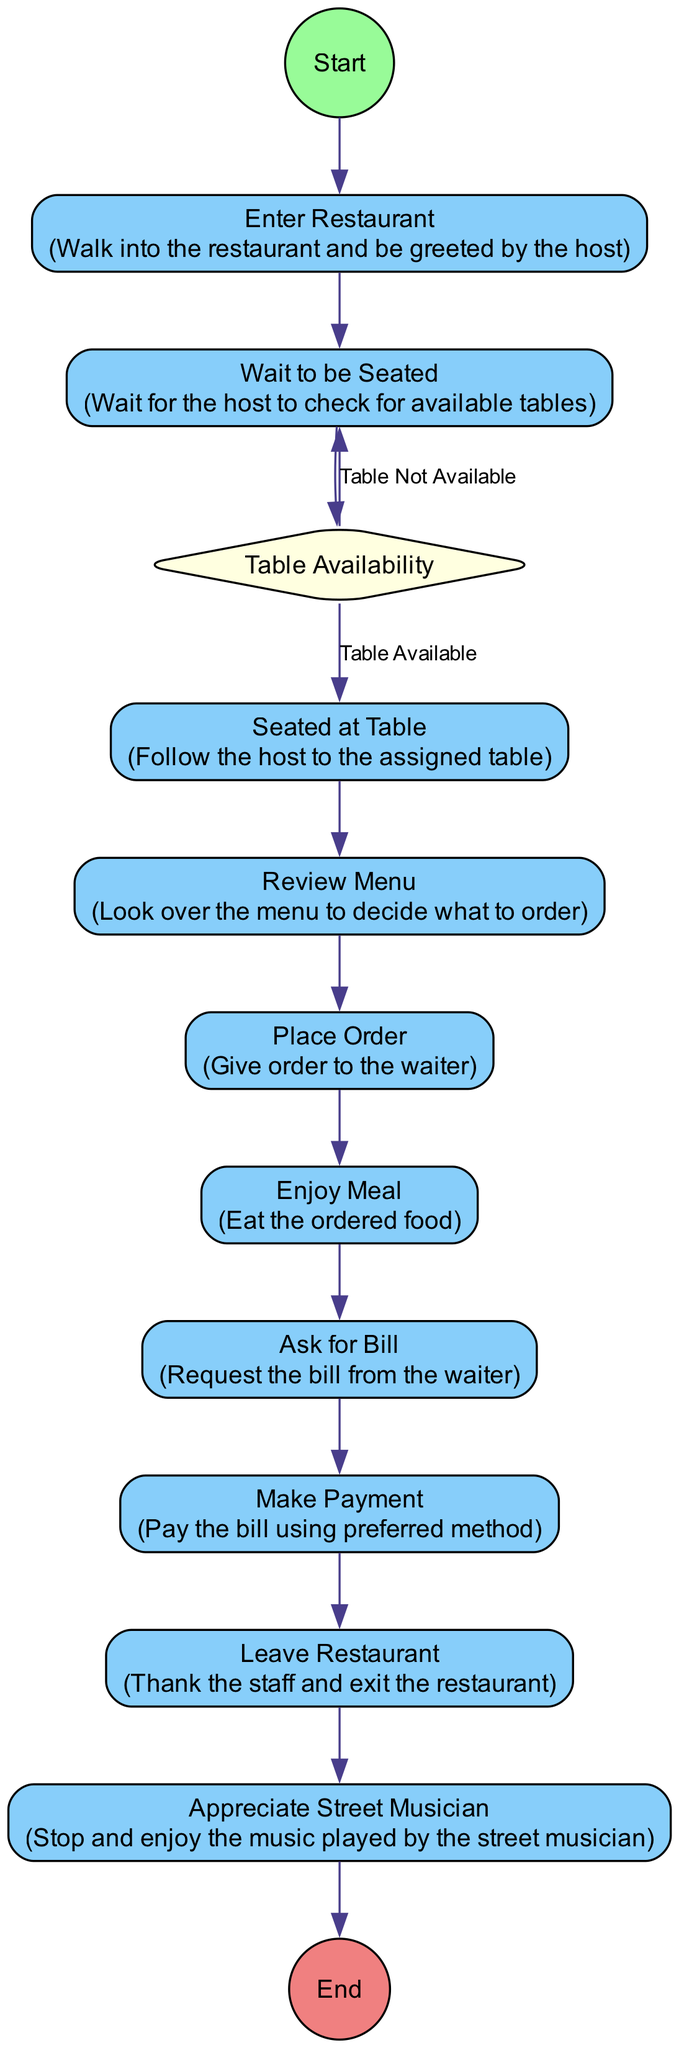What is the first activity in the diagram? The first activity depicted in the diagram is listed directly after the "Start" node, which is "Enter Restaurant."
Answer: Enter Restaurant How many activities are there in total? By counting all the listed activities within the diagram, there are ten activities including both the main actions and the appreciation of the street musician.
Answer: Ten What happens if there is no table available? If there is no table available, based on the decision node, the flow returns to "Wait to be Seated," indicating that the tourist will continue to wait for a table.
Answer: Wait to be Seated What activity comes after the "Place Order"? Following the "Place Order" activity, the next activity in the flow is "Enjoy Meal," as indicated by the order of activities in the diagram.
Answer: Enjoy Meal Which activity occurs last in the process? The last activity in the sequence is "Appreciate Street Musician," which indicates that this is an activity enjoyed after dining at the restaurant.
Answer: Appreciate Street Musician What is the decision point in the diagram? The decision point is labeled as "Table Availability," which determines whether a table is available for the tourist to be seated or if they must continue waiting.
Answer: Table Availability What action do you take after enjoying the meal? After enjoying the meal, the next action is to "Ask for Bill," indicating the workflow leading to the payment process.
Answer: Ask for Bill What type of diagram is this? This diagram is an "Activity Diagram," which illustrates the process of ordering and dining at a restaurant including decision-making elements.
Answer: Activity Diagram How many edges are connected to the decision node? There are two edges connected to the decision node, indicating the two possible transitions based on the availability of tables.
Answer: Two 